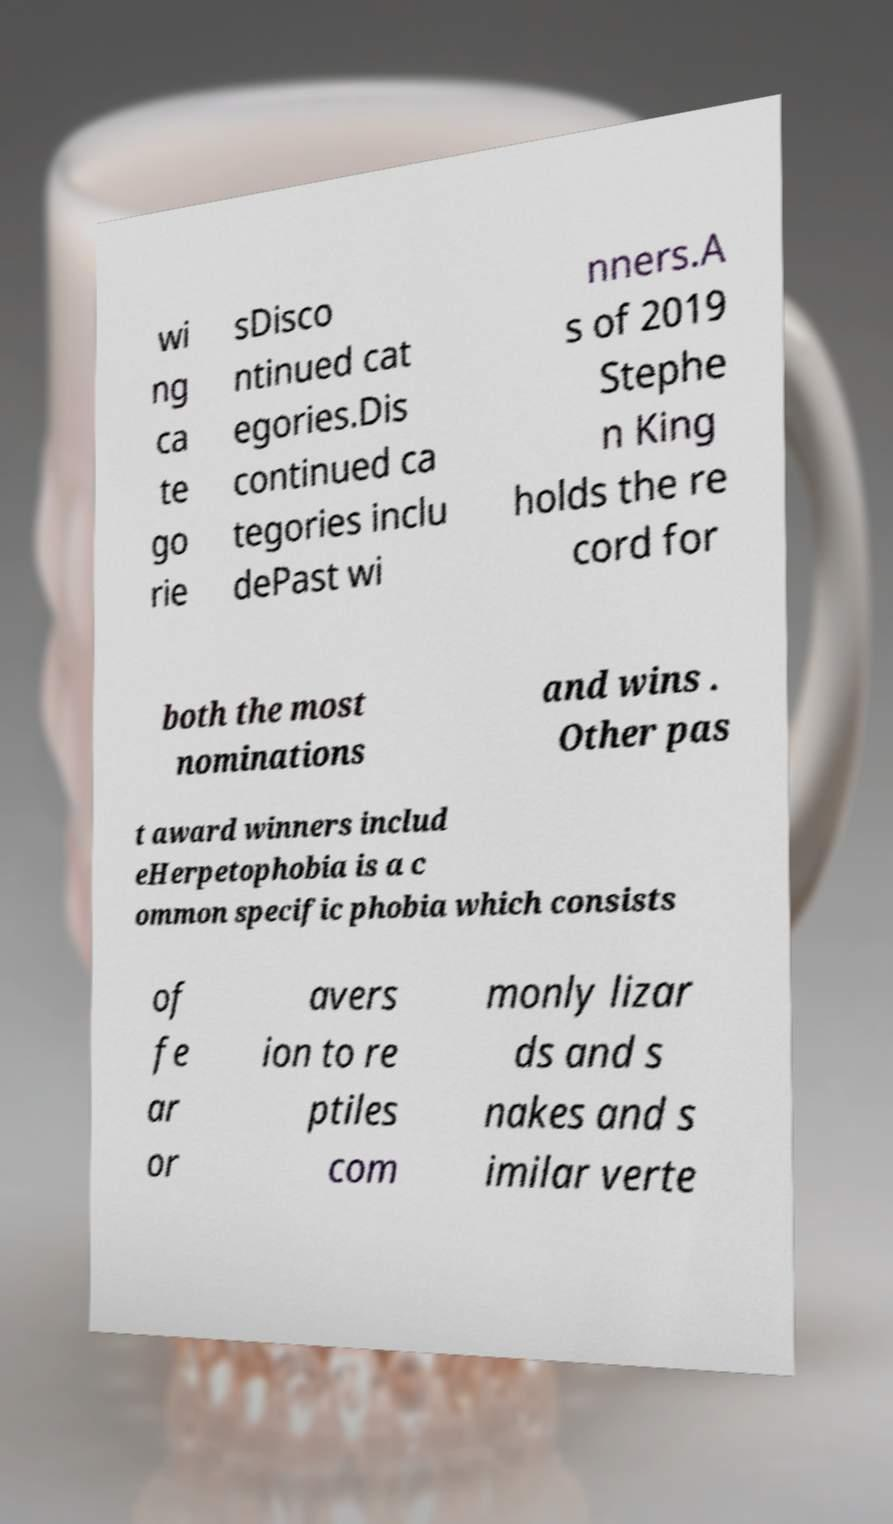Can you accurately transcribe the text from the provided image for me? wi ng ca te go rie sDisco ntinued cat egories.Dis continued ca tegories inclu dePast wi nners.A s of 2019 Stephe n King holds the re cord for both the most nominations and wins . Other pas t award winners includ eHerpetophobia is a c ommon specific phobia which consists of fe ar or avers ion to re ptiles com monly lizar ds and s nakes and s imilar verte 